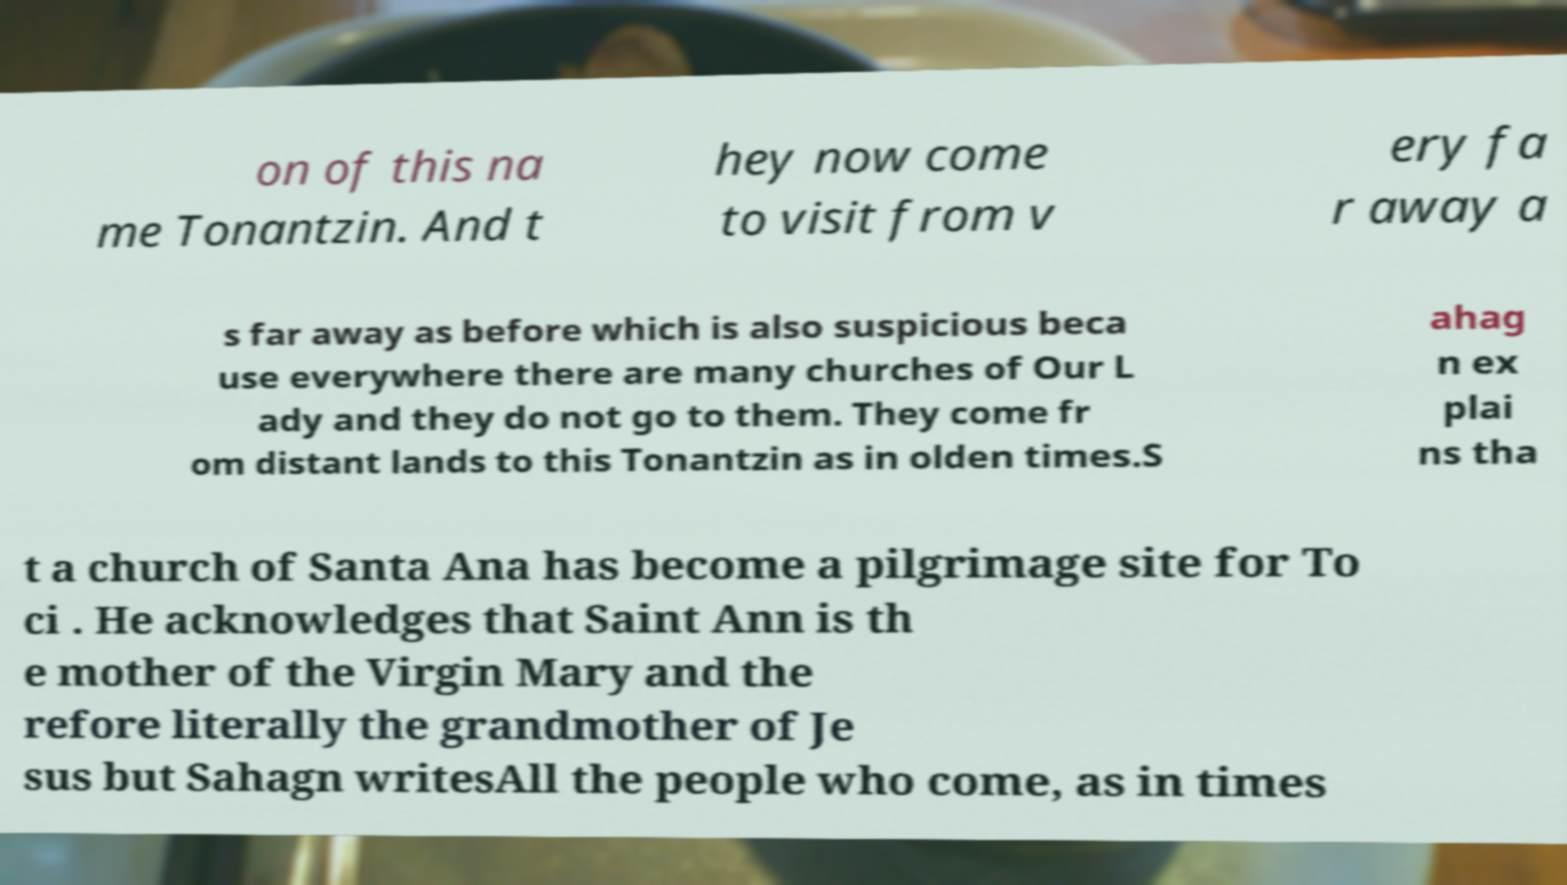For documentation purposes, I need the text within this image transcribed. Could you provide that? on of this na me Tonantzin. And t hey now come to visit from v ery fa r away a s far away as before which is also suspicious beca use everywhere there are many churches of Our L ady and they do not go to them. They come fr om distant lands to this Tonantzin as in olden times.S ahag n ex plai ns tha t a church of Santa Ana has become a pilgrimage site for To ci . He acknowledges that Saint Ann is th e mother of the Virgin Mary and the refore literally the grandmother of Je sus but Sahagn writesAll the people who come, as in times 